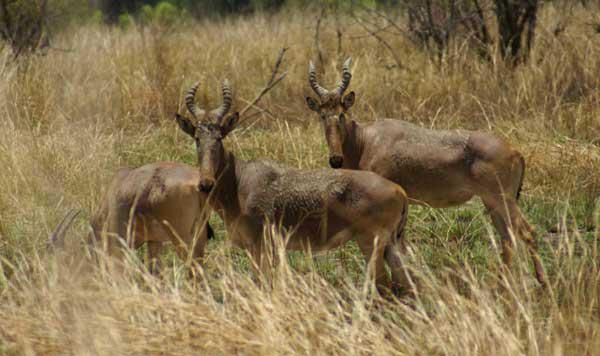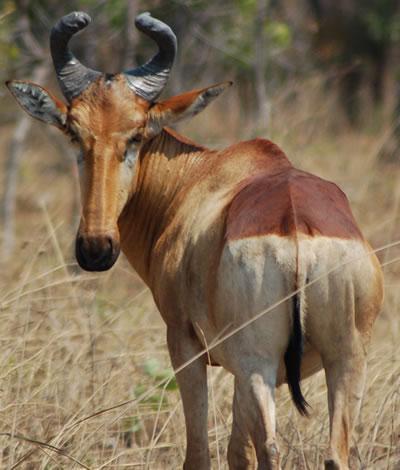The first image is the image on the left, the second image is the image on the right. Assess this claim about the two images: "There are four ruminant animals (antelope types).". Correct or not? Answer yes or no. Yes. The first image is the image on the left, the second image is the image on the right. Assess this claim about the two images: "Left image contains one horned animal, which is eyeing the camera, with its body turned rightward.". Correct or not? Answer yes or no. No. 